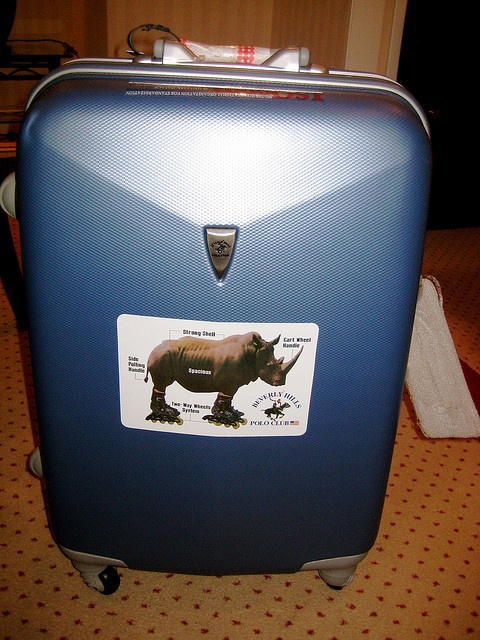Describe the objects in this image and their specific colors. I can see a suitcase in black, lightgray, navy, and gray tones in this image. 